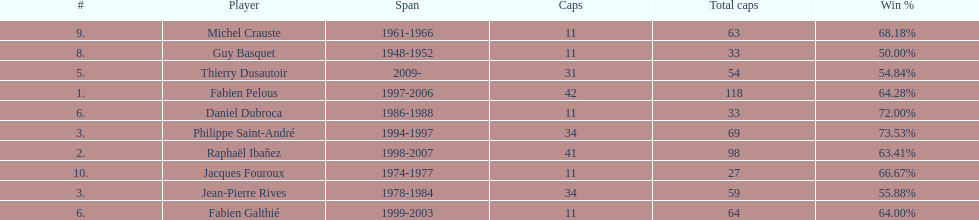How many caps did jean-pierre rives and michel crauste accrue? 122. 